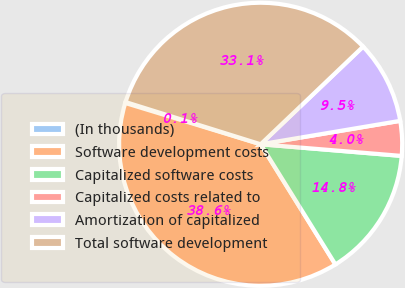<chart> <loc_0><loc_0><loc_500><loc_500><pie_chart><fcel>(In thousands)<fcel>Software development costs<fcel>Capitalized software costs<fcel>Capitalized costs related to<fcel>Amortization of capitalized<fcel>Total software development<nl><fcel>0.11%<fcel>38.57%<fcel>14.83%<fcel>3.96%<fcel>9.47%<fcel>33.06%<nl></chart> 